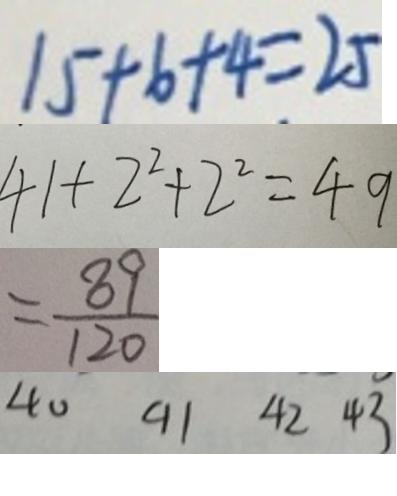<formula> <loc_0><loc_0><loc_500><loc_500>1 5 + 6 + 4 = 2 5 
 4 1 + 2 ^ { 2 } + 2 ^ { 2 } = 4 9 
 = \frac { 8 9 } { 1 2 0 } 
 4 0 9 1 4 2 4 3</formula> 